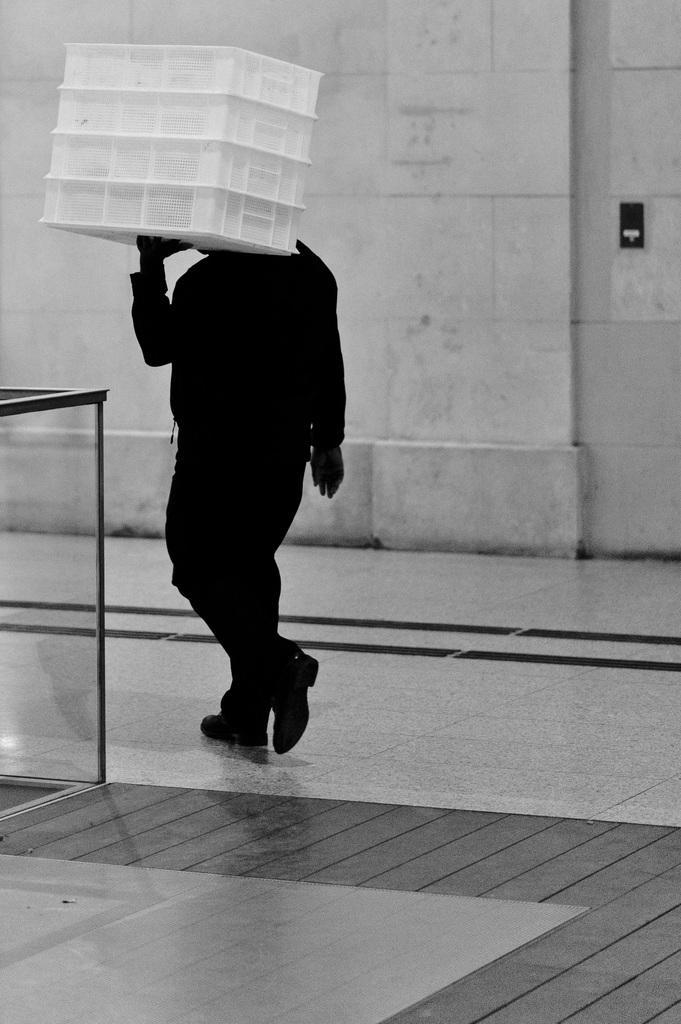How would you summarize this image in a sentence or two? This is the picture of a black and white image and we can see a person carrying an object and in the background, we can see the wall. 